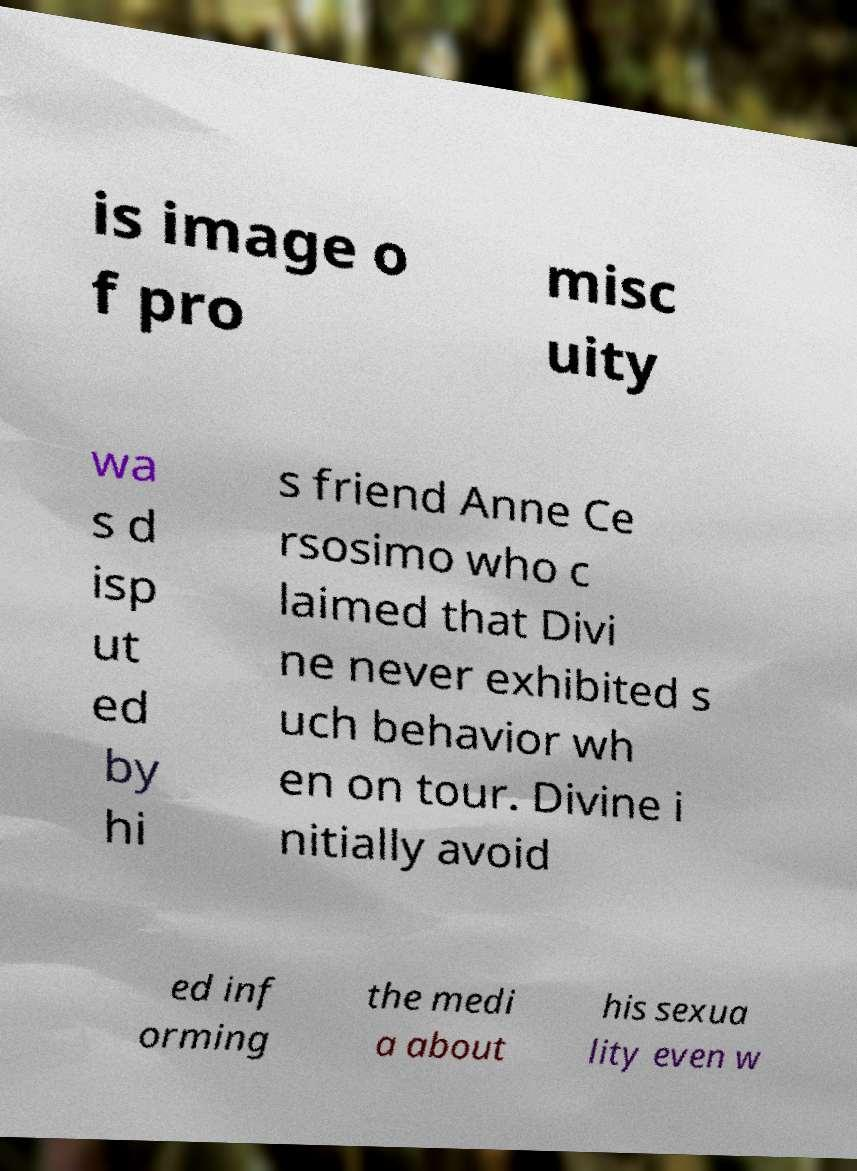Can you accurately transcribe the text from the provided image for me? is image o f pro misc uity wa s d isp ut ed by hi s friend Anne Ce rsosimo who c laimed that Divi ne never exhibited s uch behavior wh en on tour. Divine i nitially avoid ed inf orming the medi a about his sexua lity even w 